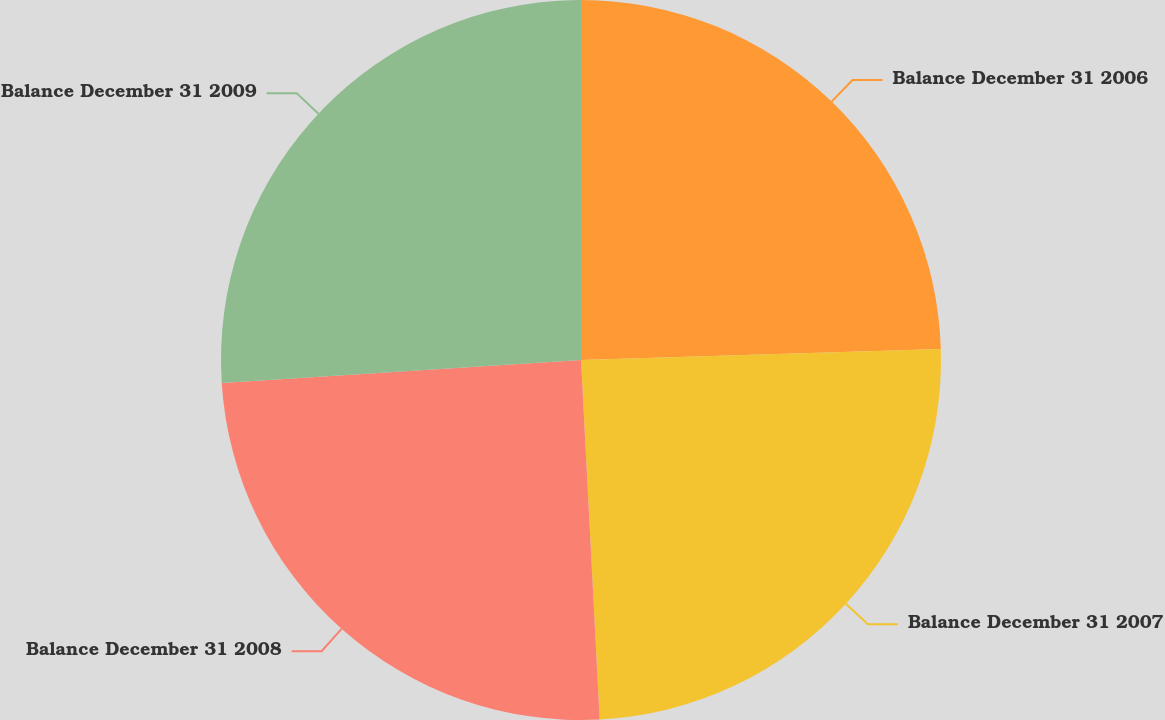<chart> <loc_0><loc_0><loc_500><loc_500><pie_chart><fcel>Balance December 31 2006<fcel>Balance December 31 2007<fcel>Balance December 31 2008<fcel>Balance December 31 2009<nl><fcel>24.51%<fcel>24.66%<fcel>24.81%<fcel>26.01%<nl></chart> 